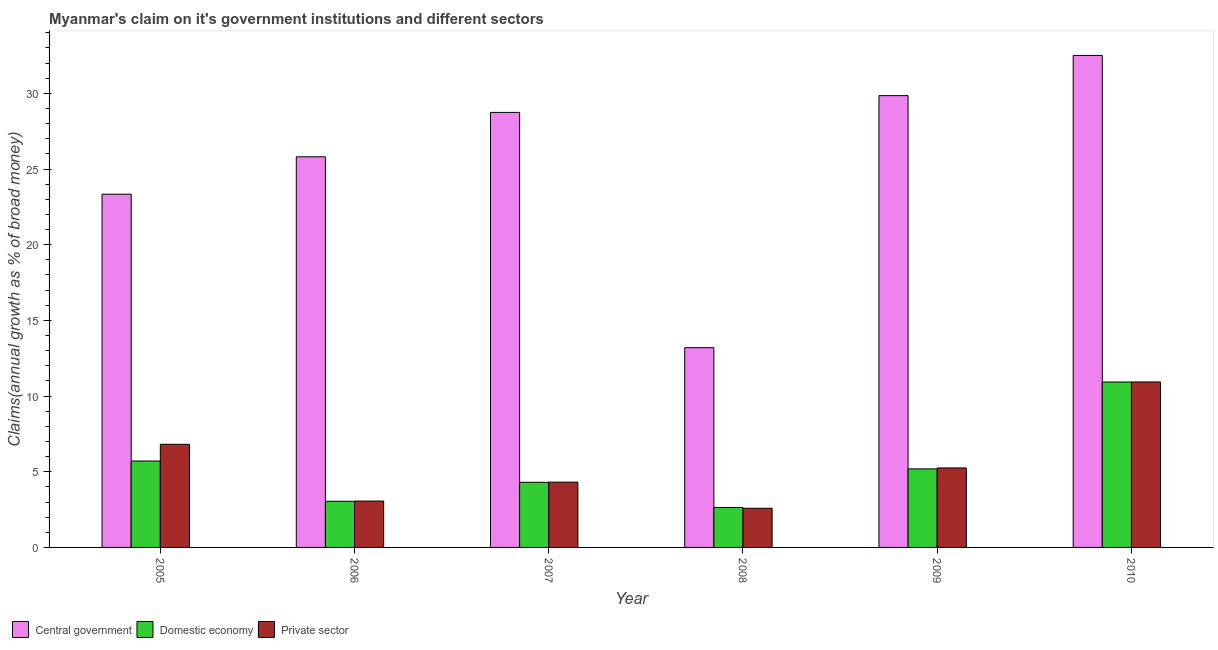How many groups of bars are there?
Your answer should be compact. 6. What is the percentage of claim on the central government in 2008?
Your answer should be very brief. 13.2. Across all years, what is the maximum percentage of claim on the domestic economy?
Your answer should be very brief. 10.93. Across all years, what is the minimum percentage of claim on the private sector?
Make the answer very short. 2.59. What is the total percentage of claim on the private sector in the graph?
Your response must be concise. 32.96. What is the difference between the percentage of claim on the private sector in 2006 and that in 2007?
Keep it short and to the point. -1.25. What is the difference between the percentage of claim on the domestic economy in 2009 and the percentage of claim on the central government in 2005?
Your response must be concise. -0.52. What is the average percentage of claim on the domestic economy per year?
Offer a very short reply. 5.3. In the year 2010, what is the difference between the percentage of claim on the domestic economy and percentage of claim on the central government?
Your answer should be very brief. 0. What is the ratio of the percentage of claim on the domestic economy in 2007 to that in 2010?
Provide a succinct answer. 0.39. Is the difference between the percentage of claim on the private sector in 2007 and 2008 greater than the difference between the percentage of claim on the central government in 2007 and 2008?
Keep it short and to the point. No. What is the difference between the highest and the second highest percentage of claim on the central government?
Keep it short and to the point. 2.66. What is the difference between the highest and the lowest percentage of claim on the domestic economy?
Give a very brief answer. 8.29. In how many years, is the percentage of claim on the private sector greater than the average percentage of claim on the private sector taken over all years?
Your answer should be compact. 2. Is the sum of the percentage of claim on the private sector in 2008 and 2010 greater than the maximum percentage of claim on the domestic economy across all years?
Keep it short and to the point. Yes. What does the 3rd bar from the left in 2005 represents?
Give a very brief answer. Private sector. What does the 3rd bar from the right in 2007 represents?
Provide a succinct answer. Central government. Is it the case that in every year, the sum of the percentage of claim on the central government and percentage of claim on the domestic economy is greater than the percentage of claim on the private sector?
Give a very brief answer. Yes. How many years are there in the graph?
Keep it short and to the point. 6. What is the difference between two consecutive major ticks on the Y-axis?
Offer a very short reply. 5. Does the graph contain any zero values?
Your response must be concise. No. How are the legend labels stacked?
Provide a short and direct response. Horizontal. What is the title of the graph?
Provide a short and direct response. Myanmar's claim on it's government institutions and different sectors. What is the label or title of the Y-axis?
Your answer should be compact. Claims(annual growth as % of broad money). What is the Claims(annual growth as % of broad money) of Central government in 2005?
Offer a very short reply. 23.34. What is the Claims(annual growth as % of broad money) in Domestic economy in 2005?
Your response must be concise. 5.71. What is the Claims(annual growth as % of broad money) in Private sector in 2005?
Ensure brevity in your answer.  6.81. What is the Claims(annual growth as % of broad money) in Central government in 2006?
Keep it short and to the point. 25.81. What is the Claims(annual growth as % of broad money) in Domestic economy in 2006?
Ensure brevity in your answer.  3.05. What is the Claims(annual growth as % of broad money) of Private sector in 2006?
Offer a very short reply. 3.06. What is the Claims(annual growth as % of broad money) of Central government in 2007?
Give a very brief answer. 28.74. What is the Claims(annual growth as % of broad money) of Domestic economy in 2007?
Keep it short and to the point. 4.3. What is the Claims(annual growth as % of broad money) in Private sector in 2007?
Give a very brief answer. 4.31. What is the Claims(annual growth as % of broad money) in Central government in 2008?
Provide a short and direct response. 13.2. What is the Claims(annual growth as % of broad money) of Domestic economy in 2008?
Give a very brief answer. 2.64. What is the Claims(annual growth as % of broad money) of Private sector in 2008?
Your answer should be very brief. 2.59. What is the Claims(annual growth as % of broad money) in Central government in 2009?
Offer a very short reply. 29.85. What is the Claims(annual growth as % of broad money) of Domestic economy in 2009?
Your answer should be very brief. 5.19. What is the Claims(annual growth as % of broad money) in Private sector in 2009?
Your answer should be compact. 5.25. What is the Claims(annual growth as % of broad money) in Central government in 2010?
Provide a succinct answer. 32.5. What is the Claims(annual growth as % of broad money) of Domestic economy in 2010?
Keep it short and to the point. 10.93. What is the Claims(annual growth as % of broad money) in Private sector in 2010?
Offer a terse response. 10.93. Across all years, what is the maximum Claims(annual growth as % of broad money) of Central government?
Offer a very short reply. 32.5. Across all years, what is the maximum Claims(annual growth as % of broad money) in Domestic economy?
Your answer should be compact. 10.93. Across all years, what is the maximum Claims(annual growth as % of broad money) in Private sector?
Give a very brief answer. 10.93. Across all years, what is the minimum Claims(annual growth as % of broad money) of Central government?
Make the answer very short. 13.2. Across all years, what is the minimum Claims(annual growth as % of broad money) of Domestic economy?
Offer a very short reply. 2.64. Across all years, what is the minimum Claims(annual growth as % of broad money) in Private sector?
Provide a short and direct response. 2.59. What is the total Claims(annual growth as % of broad money) of Central government in the graph?
Your answer should be very brief. 153.43. What is the total Claims(annual growth as % of broad money) of Domestic economy in the graph?
Your answer should be very brief. 31.82. What is the total Claims(annual growth as % of broad money) of Private sector in the graph?
Your response must be concise. 32.96. What is the difference between the Claims(annual growth as % of broad money) in Central government in 2005 and that in 2006?
Offer a terse response. -2.47. What is the difference between the Claims(annual growth as % of broad money) in Domestic economy in 2005 and that in 2006?
Offer a very short reply. 2.66. What is the difference between the Claims(annual growth as % of broad money) of Private sector in 2005 and that in 2006?
Your answer should be compact. 3.75. What is the difference between the Claims(annual growth as % of broad money) of Central government in 2005 and that in 2007?
Offer a terse response. -5.41. What is the difference between the Claims(annual growth as % of broad money) of Domestic economy in 2005 and that in 2007?
Make the answer very short. 1.41. What is the difference between the Claims(annual growth as % of broad money) of Private sector in 2005 and that in 2007?
Offer a very short reply. 2.5. What is the difference between the Claims(annual growth as % of broad money) of Central government in 2005 and that in 2008?
Give a very brief answer. 10.14. What is the difference between the Claims(annual growth as % of broad money) of Domestic economy in 2005 and that in 2008?
Your response must be concise. 3.07. What is the difference between the Claims(annual growth as % of broad money) of Private sector in 2005 and that in 2008?
Your answer should be very brief. 4.23. What is the difference between the Claims(annual growth as % of broad money) in Central government in 2005 and that in 2009?
Your answer should be very brief. -6.51. What is the difference between the Claims(annual growth as % of broad money) in Domestic economy in 2005 and that in 2009?
Make the answer very short. 0.52. What is the difference between the Claims(annual growth as % of broad money) of Private sector in 2005 and that in 2009?
Give a very brief answer. 1.56. What is the difference between the Claims(annual growth as % of broad money) of Central government in 2005 and that in 2010?
Your response must be concise. -9.17. What is the difference between the Claims(annual growth as % of broad money) in Domestic economy in 2005 and that in 2010?
Give a very brief answer. -5.22. What is the difference between the Claims(annual growth as % of broad money) of Private sector in 2005 and that in 2010?
Make the answer very short. -4.12. What is the difference between the Claims(annual growth as % of broad money) in Central government in 2006 and that in 2007?
Provide a succinct answer. -2.93. What is the difference between the Claims(annual growth as % of broad money) of Domestic economy in 2006 and that in 2007?
Provide a succinct answer. -1.25. What is the difference between the Claims(annual growth as % of broad money) in Private sector in 2006 and that in 2007?
Keep it short and to the point. -1.25. What is the difference between the Claims(annual growth as % of broad money) in Central government in 2006 and that in 2008?
Provide a succinct answer. 12.61. What is the difference between the Claims(annual growth as % of broad money) of Domestic economy in 2006 and that in 2008?
Provide a short and direct response. 0.41. What is the difference between the Claims(annual growth as % of broad money) of Private sector in 2006 and that in 2008?
Your response must be concise. 0.48. What is the difference between the Claims(annual growth as % of broad money) of Central government in 2006 and that in 2009?
Make the answer very short. -4.04. What is the difference between the Claims(annual growth as % of broad money) of Domestic economy in 2006 and that in 2009?
Ensure brevity in your answer.  -2.14. What is the difference between the Claims(annual growth as % of broad money) of Private sector in 2006 and that in 2009?
Your response must be concise. -2.19. What is the difference between the Claims(annual growth as % of broad money) of Central government in 2006 and that in 2010?
Keep it short and to the point. -6.7. What is the difference between the Claims(annual growth as % of broad money) of Domestic economy in 2006 and that in 2010?
Make the answer very short. -7.88. What is the difference between the Claims(annual growth as % of broad money) in Private sector in 2006 and that in 2010?
Your answer should be very brief. -7.87. What is the difference between the Claims(annual growth as % of broad money) of Central government in 2007 and that in 2008?
Your answer should be compact. 15.54. What is the difference between the Claims(annual growth as % of broad money) of Domestic economy in 2007 and that in 2008?
Ensure brevity in your answer.  1.66. What is the difference between the Claims(annual growth as % of broad money) in Private sector in 2007 and that in 2008?
Give a very brief answer. 1.73. What is the difference between the Claims(annual growth as % of broad money) in Central government in 2007 and that in 2009?
Offer a terse response. -1.11. What is the difference between the Claims(annual growth as % of broad money) of Domestic economy in 2007 and that in 2009?
Make the answer very short. -0.89. What is the difference between the Claims(annual growth as % of broad money) in Private sector in 2007 and that in 2009?
Offer a very short reply. -0.94. What is the difference between the Claims(annual growth as % of broad money) in Central government in 2007 and that in 2010?
Provide a short and direct response. -3.76. What is the difference between the Claims(annual growth as % of broad money) of Domestic economy in 2007 and that in 2010?
Keep it short and to the point. -6.62. What is the difference between the Claims(annual growth as % of broad money) of Private sector in 2007 and that in 2010?
Offer a terse response. -6.62. What is the difference between the Claims(annual growth as % of broad money) of Central government in 2008 and that in 2009?
Give a very brief answer. -16.65. What is the difference between the Claims(annual growth as % of broad money) in Domestic economy in 2008 and that in 2009?
Keep it short and to the point. -2.55. What is the difference between the Claims(annual growth as % of broad money) in Private sector in 2008 and that in 2009?
Offer a terse response. -2.66. What is the difference between the Claims(annual growth as % of broad money) in Central government in 2008 and that in 2010?
Your answer should be very brief. -19.31. What is the difference between the Claims(annual growth as % of broad money) in Domestic economy in 2008 and that in 2010?
Offer a very short reply. -8.29. What is the difference between the Claims(annual growth as % of broad money) of Private sector in 2008 and that in 2010?
Give a very brief answer. -8.34. What is the difference between the Claims(annual growth as % of broad money) of Central government in 2009 and that in 2010?
Give a very brief answer. -2.66. What is the difference between the Claims(annual growth as % of broad money) in Domestic economy in 2009 and that in 2010?
Your answer should be compact. -5.74. What is the difference between the Claims(annual growth as % of broad money) of Private sector in 2009 and that in 2010?
Provide a short and direct response. -5.68. What is the difference between the Claims(annual growth as % of broad money) of Central government in 2005 and the Claims(annual growth as % of broad money) of Domestic economy in 2006?
Your response must be concise. 20.29. What is the difference between the Claims(annual growth as % of broad money) in Central government in 2005 and the Claims(annual growth as % of broad money) in Private sector in 2006?
Keep it short and to the point. 20.27. What is the difference between the Claims(annual growth as % of broad money) of Domestic economy in 2005 and the Claims(annual growth as % of broad money) of Private sector in 2006?
Offer a very short reply. 2.65. What is the difference between the Claims(annual growth as % of broad money) in Central government in 2005 and the Claims(annual growth as % of broad money) in Domestic economy in 2007?
Keep it short and to the point. 19.03. What is the difference between the Claims(annual growth as % of broad money) of Central government in 2005 and the Claims(annual growth as % of broad money) of Private sector in 2007?
Offer a very short reply. 19.02. What is the difference between the Claims(annual growth as % of broad money) in Domestic economy in 2005 and the Claims(annual growth as % of broad money) in Private sector in 2007?
Your answer should be very brief. 1.4. What is the difference between the Claims(annual growth as % of broad money) of Central government in 2005 and the Claims(annual growth as % of broad money) of Domestic economy in 2008?
Your answer should be compact. 20.7. What is the difference between the Claims(annual growth as % of broad money) in Central government in 2005 and the Claims(annual growth as % of broad money) in Private sector in 2008?
Provide a short and direct response. 20.75. What is the difference between the Claims(annual growth as % of broad money) in Domestic economy in 2005 and the Claims(annual growth as % of broad money) in Private sector in 2008?
Keep it short and to the point. 3.12. What is the difference between the Claims(annual growth as % of broad money) in Central government in 2005 and the Claims(annual growth as % of broad money) in Domestic economy in 2009?
Offer a terse response. 18.15. What is the difference between the Claims(annual growth as % of broad money) of Central government in 2005 and the Claims(annual growth as % of broad money) of Private sector in 2009?
Your answer should be compact. 18.09. What is the difference between the Claims(annual growth as % of broad money) of Domestic economy in 2005 and the Claims(annual growth as % of broad money) of Private sector in 2009?
Your response must be concise. 0.46. What is the difference between the Claims(annual growth as % of broad money) in Central government in 2005 and the Claims(annual growth as % of broad money) in Domestic economy in 2010?
Provide a short and direct response. 12.41. What is the difference between the Claims(annual growth as % of broad money) in Central government in 2005 and the Claims(annual growth as % of broad money) in Private sector in 2010?
Your answer should be compact. 12.4. What is the difference between the Claims(annual growth as % of broad money) of Domestic economy in 2005 and the Claims(annual growth as % of broad money) of Private sector in 2010?
Ensure brevity in your answer.  -5.22. What is the difference between the Claims(annual growth as % of broad money) of Central government in 2006 and the Claims(annual growth as % of broad money) of Domestic economy in 2007?
Your answer should be very brief. 21.5. What is the difference between the Claims(annual growth as % of broad money) in Central government in 2006 and the Claims(annual growth as % of broad money) in Private sector in 2007?
Provide a succinct answer. 21.49. What is the difference between the Claims(annual growth as % of broad money) in Domestic economy in 2006 and the Claims(annual growth as % of broad money) in Private sector in 2007?
Provide a short and direct response. -1.26. What is the difference between the Claims(annual growth as % of broad money) in Central government in 2006 and the Claims(annual growth as % of broad money) in Domestic economy in 2008?
Your response must be concise. 23.17. What is the difference between the Claims(annual growth as % of broad money) of Central government in 2006 and the Claims(annual growth as % of broad money) of Private sector in 2008?
Your answer should be very brief. 23.22. What is the difference between the Claims(annual growth as % of broad money) of Domestic economy in 2006 and the Claims(annual growth as % of broad money) of Private sector in 2008?
Keep it short and to the point. 0.46. What is the difference between the Claims(annual growth as % of broad money) in Central government in 2006 and the Claims(annual growth as % of broad money) in Domestic economy in 2009?
Make the answer very short. 20.62. What is the difference between the Claims(annual growth as % of broad money) of Central government in 2006 and the Claims(annual growth as % of broad money) of Private sector in 2009?
Provide a succinct answer. 20.56. What is the difference between the Claims(annual growth as % of broad money) in Domestic economy in 2006 and the Claims(annual growth as % of broad money) in Private sector in 2009?
Make the answer very short. -2.2. What is the difference between the Claims(annual growth as % of broad money) in Central government in 2006 and the Claims(annual growth as % of broad money) in Domestic economy in 2010?
Provide a short and direct response. 14.88. What is the difference between the Claims(annual growth as % of broad money) of Central government in 2006 and the Claims(annual growth as % of broad money) of Private sector in 2010?
Make the answer very short. 14.88. What is the difference between the Claims(annual growth as % of broad money) of Domestic economy in 2006 and the Claims(annual growth as % of broad money) of Private sector in 2010?
Ensure brevity in your answer.  -7.88. What is the difference between the Claims(annual growth as % of broad money) in Central government in 2007 and the Claims(annual growth as % of broad money) in Domestic economy in 2008?
Your answer should be compact. 26.1. What is the difference between the Claims(annual growth as % of broad money) of Central government in 2007 and the Claims(annual growth as % of broad money) of Private sector in 2008?
Make the answer very short. 26.15. What is the difference between the Claims(annual growth as % of broad money) of Domestic economy in 2007 and the Claims(annual growth as % of broad money) of Private sector in 2008?
Your answer should be compact. 1.72. What is the difference between the Claims(annual growth as % of broad money) in Central government in 2007 and the Claims(annual growth as % of broad money) in Domestic economy in 2009?
Your answer should be very brief. 23.55. What is the difference between the Claims(annual growth as % of broad money) of Central government in 2007 and the Claims(annual growth as % of broad money) of Private sector in 2009?
Keep it short and to the point. 23.49. What is the difference between the Claims(annual growth as % of broad money) in Domestic economy in 2007 and the Claims(annual growth as % of broad money) in Private sector in 2009?
Make the answer very short. -0.95. What is the difference between the Claims(annual growth as % of broad money) in Central government in 2007 and the Claims(annual growth as % of broad money) in Domestic economy in 2010?
Give a very brief answer. 17.81. What is the difference between the Claims(annual growth as % of broad money) of Central government in 2007 and the Claims(annual growth as % of broad money) of Private sector in 2010?
Provide a succinct answer. 17.81. What is the difference between the Claims(annual growth as % of broad money) in Domestic economy in 2007 and the Claims(annual growth as % of broad money) in Private sector in 2010?
Your answer should be compact. -6.63. What is the difference between the Claims(annual growth as % of broad money) of Central government in 2008 and the Claims(annual growth as % of broad money) of Domestic economy in 2009?
Your answer should be very brief. 8.01. What is the difference between the Claims(annual growth as % of broad money) in Central government in 2008 and the Claims(annual growth as % of broad money) in Private sector in 2009?
Give a very brief answer. 7.95. What is the difference between the Claims(annual growth as % of broad money) in Domestic economy in 2008 and the Claims(annual growth as % of broad money) in Private sector in 2009?
Offer a very short reply. -2.61. What is the difference between the Claims(annual growth as % of broad money) in Central government in 2008 and the Claims(annual growth as % of broad money) in Domestic economy in 2010?
Provide a short and direct response. 2.27. What is the difference between the Claims(annual growth as % of broad money) of Central government in 2008 and the Claims(annual growth as % of broad money) of Private sector in 2010?
Offer a very short reply. 2.27. What is the difference between the Claims(annual growth as % of broad money) in Domestic economy in 2008 and the Claims(annual growth as % of broad money) in Private sector in 2010?
Make the answer very short. -8.29. What is the difference between the Claims(annual growth as % of broad money) of Central government in 2009 and the Claims(annual growth as % of broad money) of Domestic economy in 2010?
Ensure brevity in your answer.  18.92. What is the difference between the Claims(annual growth as % of broad money) of Central government in 2009 and the Claims(annual growth as % of broad money) of Private sector in 2010?
Your answer should be very brief. 18.92. What is the difference between the Claims(annual growth as % of broad money) of Domestic economy in 2009 and the Claims(annual growth as % of broad money) of Private sector in 2010?
Offer a terse response. -5.74. What is the average Claims(annual growth as % of broad money) in Central government per year?
Ensure brevity in your answer.  25.57. What is the average Claims(annual growth as % of broad money) of Domestic economy per year?
Ensure brevity in your answer.  5.3. What is the average Claims(annual growth as % of broad money) in Private sector per year?
Your answer should be compact. 5.49. In the year 2005, what is the difference between the Claims(annual growth as % of broad money) of Central government and Claims(annual growth as % of broad money) of Domestic economy?
Keep it short and to the point. 17.63. In the year 2005, what is the difference between the Claims(annual growth as % of broad money) of Central government and Claims(annual growth as % of broad money) of Private sector?
Make the answer very short. 16.52. In the year 2005, what is the difference between the Claims(annual growth as % of broad money) in Domestic economy and Claims(annual growth as % of broad money) in Private sector?
Your answer should be very brief. -1.1. In the year 2006, what is the difference between the Claims(annual growth as % of broad money) in Central government and Claims(annual growth as % of broad money) in Domestic economy?
Make the answer very short. 22.76. In the year 2006, what is the difference between the Claims(annual growth as % of broad money) of Central government and Claims(annual growth as % of broad money) of Private sector?
Your response must be concise. 22.74. In the year 2006, what is the difference between the Claims(annual growth as % of broad money) in Domestic economy and Claims(annual growth as % of broad money) in Private sector?
Offer a terse response. -0.01. In the year 2007, what is the difference between the Claims(annual growth as % of broad money) in Central government and Claims(annual growth as % of broad money) in Domestic economy?
Make the answer very short. 24.44. In the year 2007, what is the difference between the Claims(annual growth as % of broad money) of Central government and Claims(annual growth as % of broad money) of Private sector?
Offer a terse response. 24.43. In the year 2007, what is the difference between the Claims(annual growth as % of broad money) of Domestic economy and Claims(annual growth as % of broad money) of Private sector?
Provide a short and direct response. -0.01. In the year 2008, what is the difference between the Claims(annual growth as % of broad money) in Central government and Claims(annual growth as % of broad money) in Domestic economy?
Keep it short and to the point. 10.56. In the year 2008, what is the difference between the Claims(annual growth as % of broad money) in Central government and Claims(annual growth as % of broad money) in Private sector?
Offer a very short reply. 10.61. In the year 2008, what is the difference between the Claims(annual growth as % of broad money) of Domestic economy and Claims(annual growth as % of broad money) of Private sector?
Your answer should be compact. 0.05. In the year 2009, what is the difference between the Claims(annual growth as % of broad money) of Central government and Claims(annual growth as % of broad money) of Domestic economy?
Give a very brief answer. 24.66. In the year 2009, what is the difference between the Claims(annual growth as % of broad money) of Central government and Claims(annual growth as % of broad money) of Private sector?
Give a very brief answer. 24.6. In the year 2009, what is the difference between the Claims(annual growth as % of broad money) in Domestic economy and Claims(annual growth as % of broad money) in Private sector?
Ensure brevity in your answer.  -0.06. In the year 2010, what is the difference between the Claims(annual growth as % of broad money) in Central government and Claims(annual growth as % of broad money) in Domestic economy?
Make the answer very short. 21.58. In the year 2010, what is the difference between the Claims(annual growth as % of broad money) of Central government and Claims(annual growth as % of broad money) of Private sector?
Your answer should be compact. 21.57. In the year 2010, what is the difference between the Claims(annual growth as % of broad money) of Domestic economy and Claims(annual growth as % of broad money) of Private sector?
Keep it short and to the point. -0. What is the ratio of the Claims(annual growth as % of broad money) in Central government in 2005 to that in 2006?
Ensure brevity in your answer.  0.9. What is the ratio of the Claims(annual growth as % of broad money) of Domestic economy in 2005 to that in 2006?
Offer a terse response. 1.87. What is the ratio of the Claims(annual growth as % of broad money) of Private sector in 2005 to that in 2006?
Your answer should be very brief. 2.22. What is the ratio of the Claims(annual growth as % of broad money) of Central government in 2005 to that in 2007?
Give a very brief answer. 0.81. What is the ratio of the Claims(annual growth as % of broad money) in Domestic economy in 2005 to that in 2007?
Provide a succinct answer. 1.33. What is the ratio of the Claims(annual growth as % of broad money) of Private sector in 2005 to that in 2007?
Offer a terse response. 1.58. What is the ratio of the Claims(annual growth as % of broad money) of Central government in 2005 to that in 2008?
Offer a terse response. 1.77. What is the ratio of the Claims(annual growth as % of broad money) in Domestic economy in 2005 to that in 2008?
Provide a succinct answer. 2.16. What is the ratio of the Claims(annual growth as % of broad money) in Private sector in 2005 to that in 2008?
Offer a terse response. 2.63. What is the ratio of the Claims(annual growth as % of broad money) in Central government in 2005 to that in 2009?
Your answer should be compact. 0.78. What is the ratio of the Claims(annual growth as % of broad money) of Domestic economy in 2005 to that in 2009?
Give a very brief answer. 1.1. What is the ratio of the Claims(annual growth as % of broad money) in Private sector in 2005 to that in 2009?
Your answer should be very brief. 1.3. What is the ratio of the Claims(annual growth as % of broad money) of Central government in 2005 to that in 2010?
Provide a short and direct response. 0.72. What is the ratio of the Claims(annual growth as % of broad money) in Domestic economy in 2005 to that in 2010?
Provide a short and direct response. 0.52. What is the ratio of the Claims(annual growth as % of broad money) of Private sector in 2005 to that in 2010?
Your answer should be very brief. 0.62. What is the ratio of the Claims(annual growth as % of broad money) of Central government in 2006 to that in 2007?
Ensure brevity in your answer.  0.9. What is the ratio of the Claims(annual growth as % of broad money) of Domestic economy in 2006 to that in 2007?
Keep it short and to the point. 0.71. What is the ratio of the Claims(annual growth as % of broad money) in Private sector in 2006 to that in 2007?
Ensure brevity in your answer.  0.71. What is the ratio of the Claims(annual growth as % of broad money) in Central government in 2006 to that in 2008?
Provide a succinct answer. 1.96. What is the ratio of the Claims(annual growth as % of broad money) in Domestic economy in 2006 to that in 2008?
Provide a succinct answer. 1.16. What is the ratio of the Claims(annual growth as % of broad money) of Private sector in 2006 to that in 2008?
Your answer should be compact. 1.18. What is the ratio of the Claims(annual growth as % of broad money) in Central government in 2006 to that in 2009?
Make the answer very short. 0.86. What is the ratio of the Claims(annual growth as % of broad money) in Domestic economy in 2006 to that in 2009?
Provide a short and direct response. 0.59. What is the ratio of the Claims(annual growth as % of broad money) of Private sector in 2006 to that in 2009?
Provide a short and direct response. 0.58. What is the ratio of the Claims(annual growth as % of broad money) in Central government in 2006 to that in 2010?
Make the answer very short. 0.79. What is the ratio of the Claims(annual growth as % of broad money) of Domestic economy in 2006 to that in 2010?
Offer a terse response. 0.28. What is the ratio of the Claims(annual growth as % of broad money) in Private sector in 2006 to that in 2010?
Ensure brevity in your answer.  0.28. What is the ratio of the Claims(annual growth as % of broad money) in Central government in 2007 to that in 2008?
Your answer should be compact. 2.18. What is the ratio of the Claims(annual growth as % of broad money) of Domestic economy in 2007 to that in 2008?
Your response must be concise. 1.63. What is the ratio of the Claims(annual growth as % of broad money) in Private sector in 2007 to that in 2008?
Provide a succinct answer. 1.67. What is the ratio of the Claims(annual growth as % of broad money) of Central government in 2007 to that in 2009?
Give a very brief answer. 0.96. What is the ratio of the Claims(annual growth as % of broad money) of Domestic economy in 2007 to that in 2009?
Keep it short and to the point. 0.83. What is the ratio of the Claims(annual growth as % of broad money) in Private sector in 2007 to that in 2009?
Provide a short and direct response. 0.82. What is the ratio of the Claims(annual growth as % of broad money) in Central government in 2007 to that in 2010?
Your answer should be very brief. 0.88. What is the ratio of the Claims(annual growth as % of broad money) of Domestic economy in 2007 to that in 2010?
Your answer should be very brief. 0.39. What is the ratio of the Claims(annual growth as % of broad money) of Private sector in 2007 to that in 2010?
Keep it short and to the point. 0.39. What is the ratio of the Claims(annual growth as % of broad money) in Central government in 2008 to that in 2009?
Offer a terse response. 0.44. What is the ratio of the Claims(annual growth as % of broad money) in Domestic economy in 2008 to that in 2009?
Make the answer very short. 0.51. What is the ratio of the Claims(annual growth as % of broad money) in Private sector in 2008 to that in 2009?
Your answer should be compact. 0.49. What is the ratio of the Claims(annual growth as % of broad money) in Central government in 2008 to that in 2010?
Keep it short and to the point. 0.41. What is the ratio of the Claims(annual growth as % of broad money) of Domestic economy in 2008 to that in 2010?
Your answer should be very brief. 0.24. What is the ratio of the Claims(annual growth as % of broad money) of Private sector in 2008 to that in 2010?
Offer a very short reply. 0.24. What is the ratio of the Claims(annual growth as % of broad money) in Central government in 2009 to that in 2010?
Keep it short and to the point. 0.92. What is the ratio of the Claims(annual growth as % of broad money) in Domestic economy in 2009 to that in 2010?
Offer a terse response. 0.47. What is the ratio of the Claims(annual growth as % of broad money) of Private sector in 2009 to that in 2010?
Give a very brief answer. 0.48. What is the difference between the highest and the second highest Claims(annual growth as % of broad money) in Central government?
Give a very brief answer. 2.66. What is the difference between the highest and the second highest Claims(annual growth as % of broad money) of Domestic economy?
Your answer should be compact. 5.22. What is the difference between the highest and the second highest Claims(annual growth as % of broad money) in Private sector?
Your answer should be very brief. 4.12. What is the difference between the highest and the lowest Claims(annual growth as % of broad money) of Central government?
Provide a succinct answer. 19.31. What is the difference between the highest and the lowest Claims(annual growth as % of broad money) in Domestic economy?
Your response must be concise. 8.29. What is the difference between the highest and the lowest Claims(annual growth as % of broad money) of Private sector?
Offer a very short reply. 8.34. 